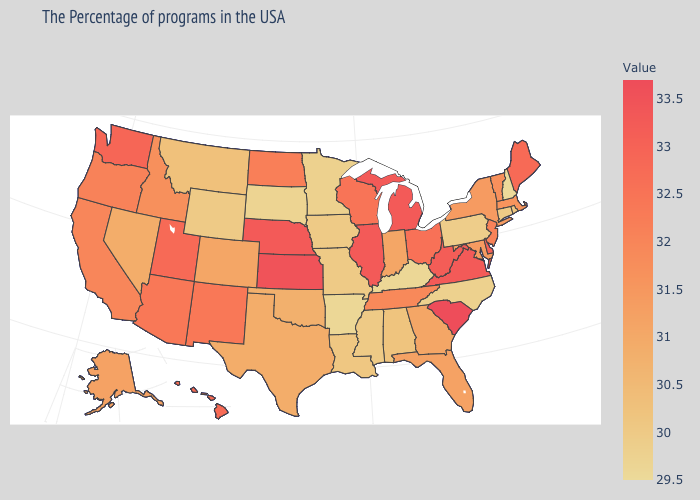Does New Hampshire have the lowest value in the Northeast?
Write a very short answer. Yes. Among the states that border Arizona , does Colorado have the lowest value?
Keep it brief. No. Does the map have missing data?
Answer briefly. No. Which states have the lowest value in the USA?
Answer briefly. New Hampshire. Does the map have missing data?
Quick response, please. No. 